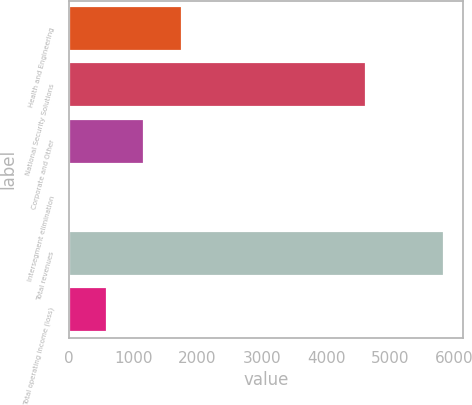Convert chart to OTSL. <chart><loc_0><loc_0><loc_500><loc_500><bar_chart><fcel>Health and Engineering<fcel>National Security Solutions<fcel>Corporate and Other<fcel>Intersegment elimination<fcel>Total revenues<fcel>Total operating income (loss)<nl><fcel>1753.6<fcel>4618<fcel>1170.4<fcel>4<fcel>5836<fcel>587.2<nl></chart> 